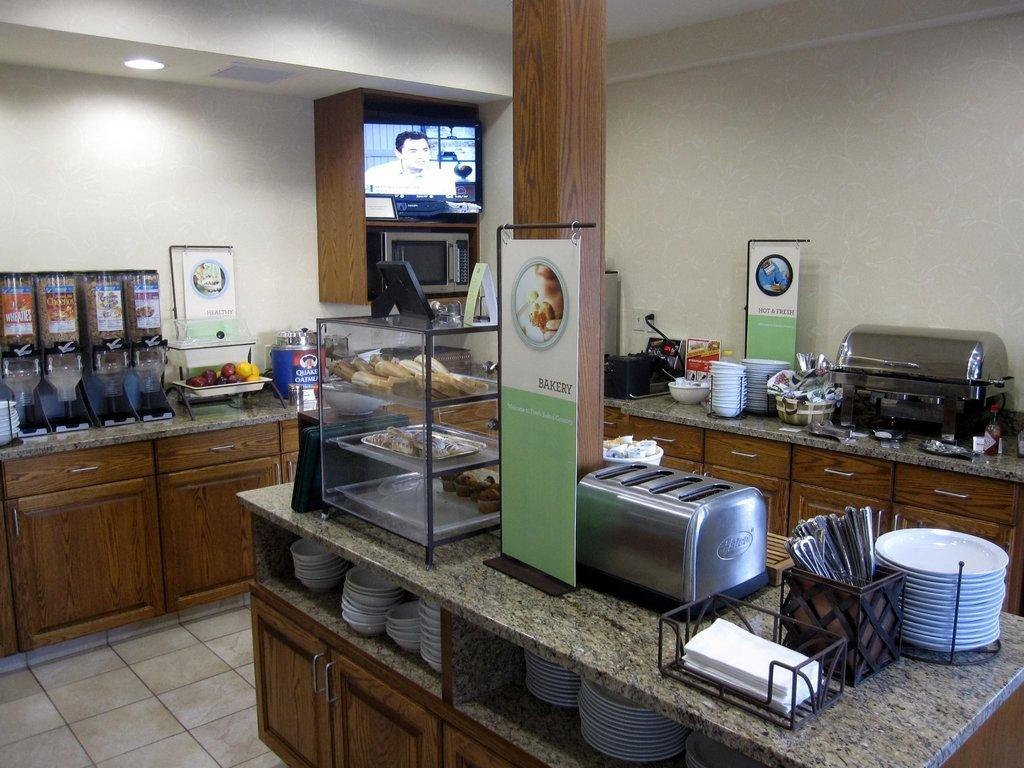<image>
Present a compact description of the photo's key features. countertops with different foods for breakfast with the closest one labeled bakery 